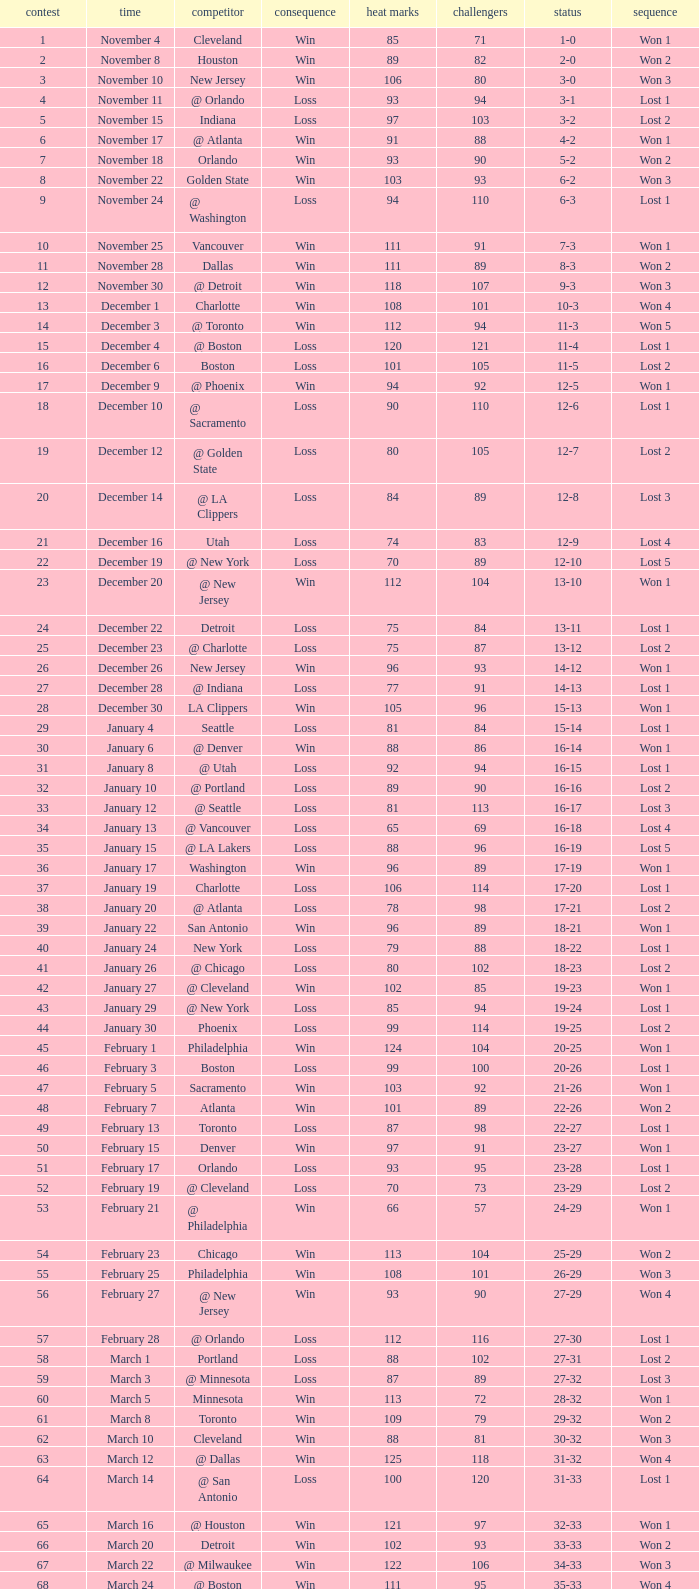What is the average Heat Points, when Result is "Loss", when Game is greater than 72, and when Date is "April 21"? 92.0. 